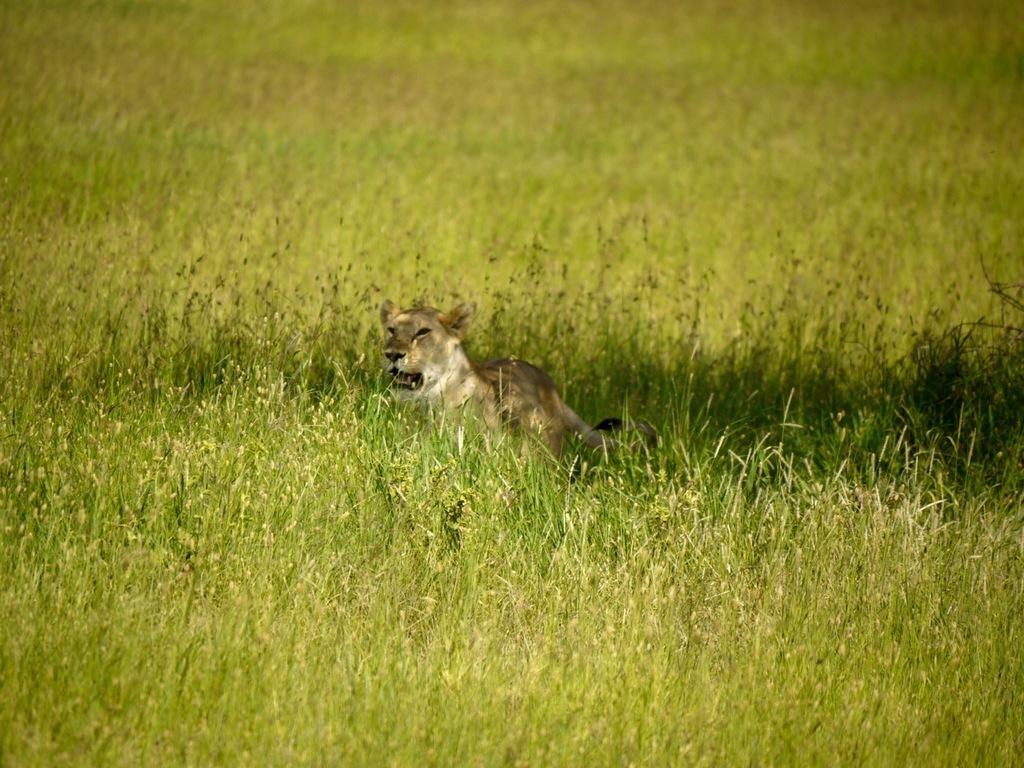Can you describe this image briefly? Here we can see animal and green grass. 